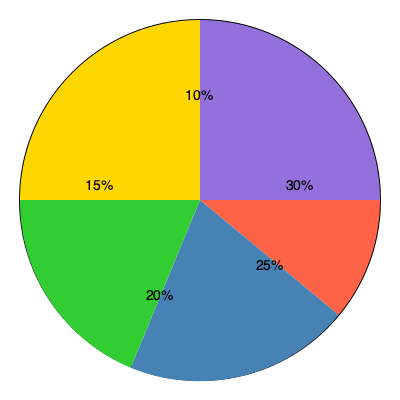As a budget-conscious accountant for a major film studio, you're reviewing the proposed budget allocation for an upcoming blockbuster film. The pie chart shows the distribution of the film's $100 million budget across five main categories. If the studio executives decide to increase the special effects budget by 20% of its current allocation, how much additional funding (in millions of dollars) would need to be secured to maintain the same total budget while keeping all other category allocations unchanged? To solve this problem, we'll follow these steps:

1. Identify the special effects budget percentage: 30%

2. Calculate the current special effects budget:
   $100 million \times 30\% = $30 million

3. Calculate the 20% increase in the special effects budget:
   $30 million \times 20\% = $6 million

4. The new special effects budget would be:
   $30 million + $6 million = $36 million

5. Calculate the new total budget if we maintain other categories:
   Original budget + Increase = $100 million + $6 million = $106 million

6. The additional funding needed is the difference between the new total budget and the original budget:
   $106 million - $100 million = $6 million

Therefore, an additional $6 million would need to be secured to maintain the same total budget while increasing the special effects budget by 20% and keeping all other category allocations unchanged.
Answer: $6 million 